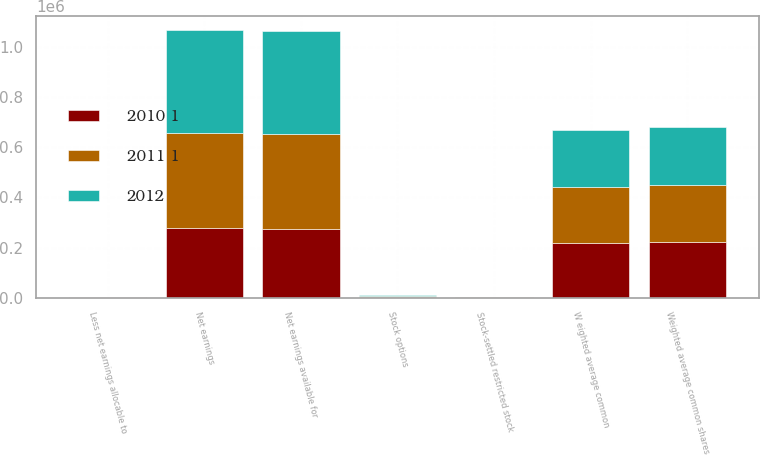Convert chart to OTSL. <chart><loc_0><loc_0><loc_500><loc_500><stacked_bar_chart><ecel><fcel>Net earnings<fcel>Less net earnings allocable to<fcel>Net earnings available for<fcel>W eighted average common<fcel>Stock options<fcel>Stock-settled restricted stock<fcel>Weighted average common shares<nl><fcel>2012<fcel>413795<fcel>166<fcel>413629<fcel>226282<fcel>3608<fcel>831<fcel>230721<nl><fcel>2011 1<fcel>377495<fcel>1623<fcel>375910<fcel>223449<fcel>3540<fcel>612<fcel>227601<nl><fcel>2010 1<fcel>277844<fcel>2344<fcel>275528<fcel>219527<fcel>2415<fcel>292<fcel>222234<nl></chart> 